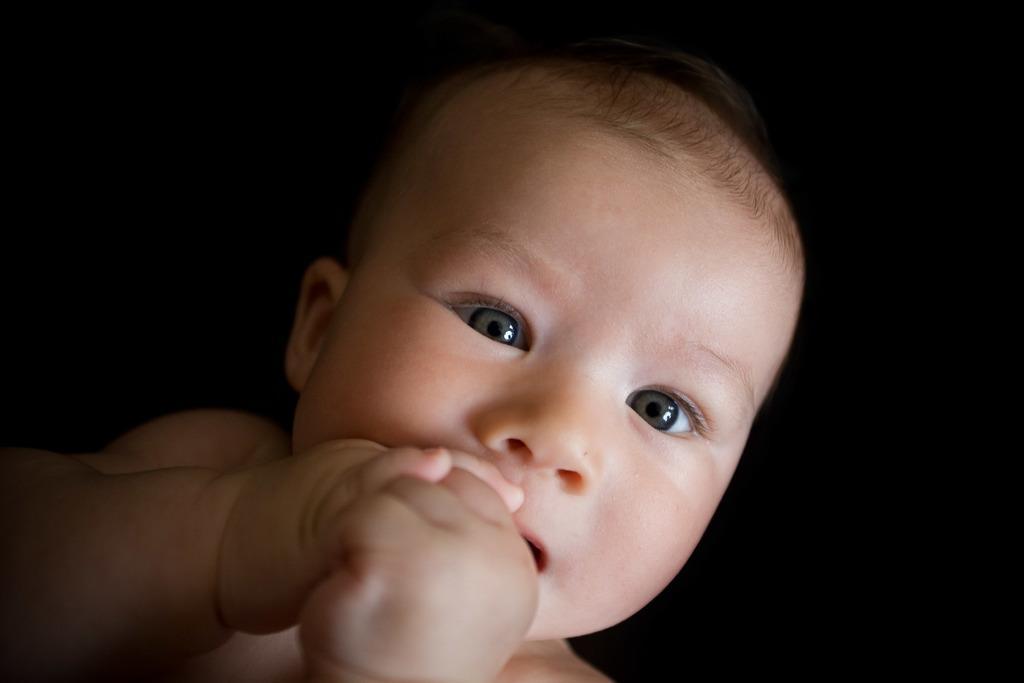How would you summarize this image in a sentence or two? In this image I can see a baby and I can see the black background. 